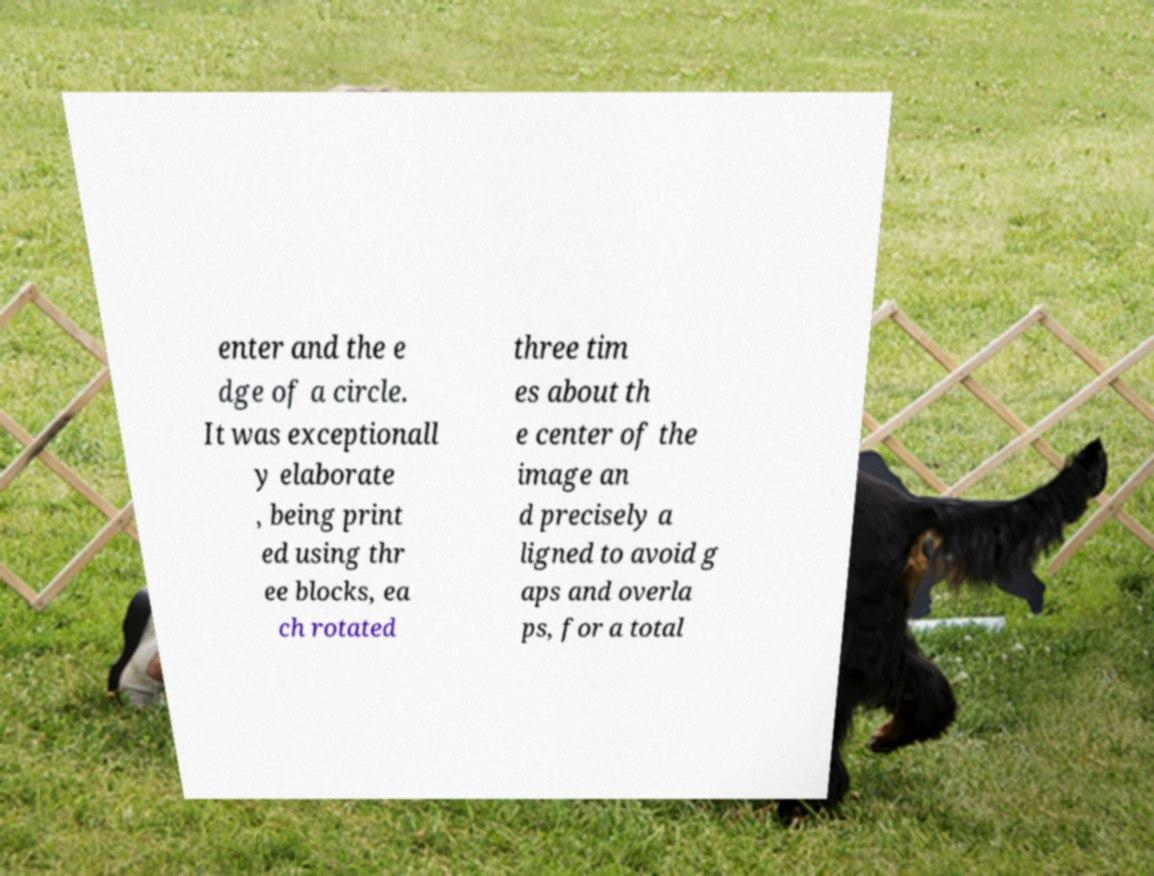Can you accurately transcribe the text from the provided image for me? enter and the e dge of a circle. It was exceptionall y elaborate , being print ed using thr ee blocks, ea ch rotated three tim es about th e center of the image an d precisely a ligned to avoid g aps and overla ps, for a total 